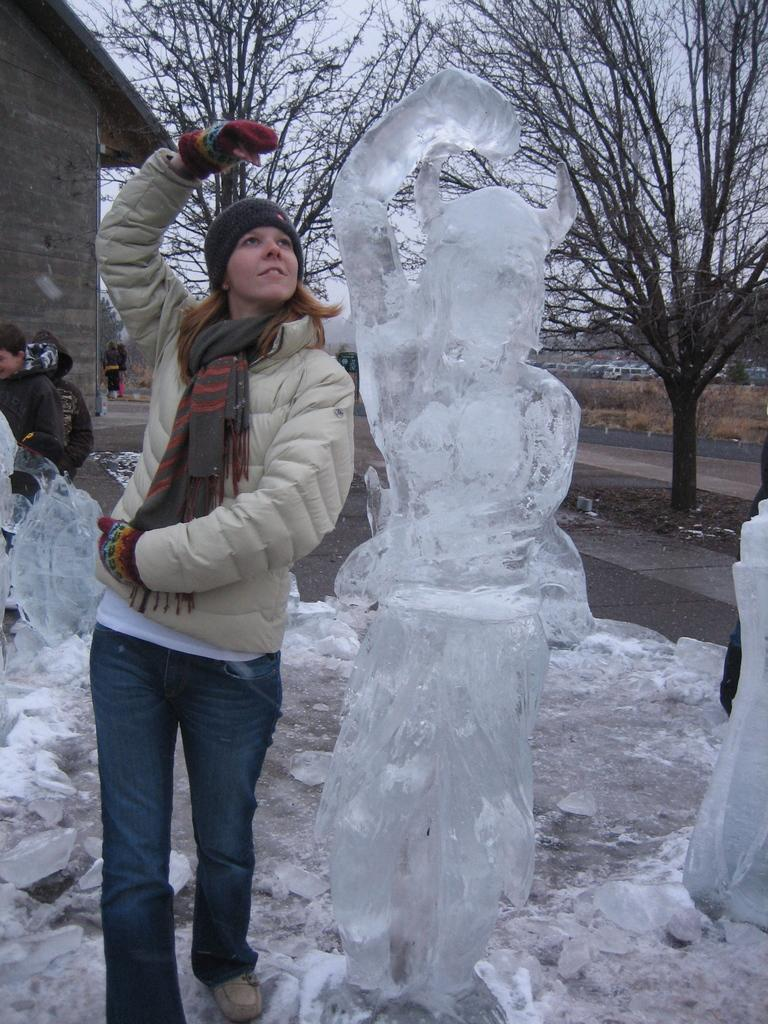Who or what can be seen in the image? There are people in the image. What type of artwork is present in the image? There are ice sculptures in the image. What can be seen in the background of the image? There is a wall, trees, grass, and the sky visible in the background of the image. How does the guide help the team in the image? There is no guide or team present in the image; it features people and ice sculptures. What type of pollution can be seen in the image? There is no pollution visible in the image; it is focused on people, ice sculptures, and the surrounding environment. 